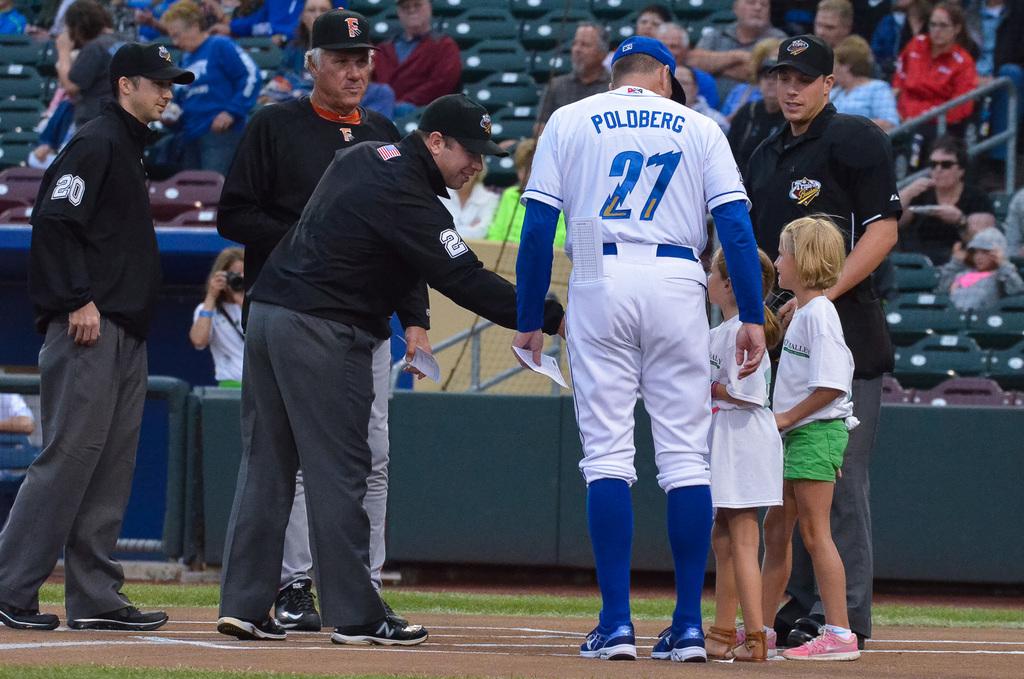Who is playing in the game?
Provide a short and direct response. Poldberg. What is the number on the back of his white jersey?
Your answer should be compact. 27. 